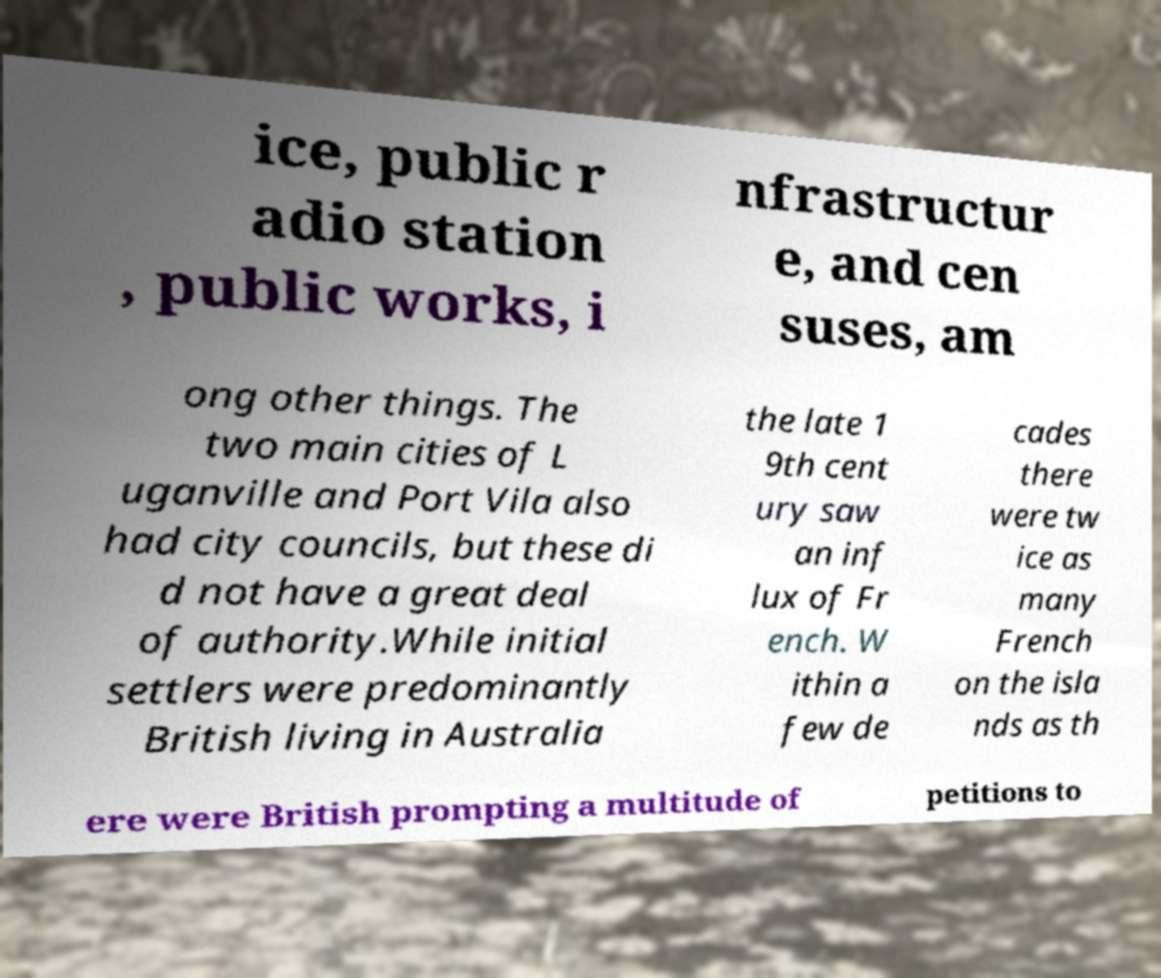For documentation purposes, I need the text within this image transcribed. Could you provide that? ice, public r adio station , public works, i nfrastructur e, and cen suses, am ong other things. The two main cities of L uganville and Port Vila also had city councils, but these di d not have a great deal of authority.While initial settlers were predominantly British living in Australia the late 1 9th cent ury saw an inf lux of Fr ench. W ithin a few de cades there were tw ice as many French on the isla nds as th ere were British prompting a multitude of petitions to 